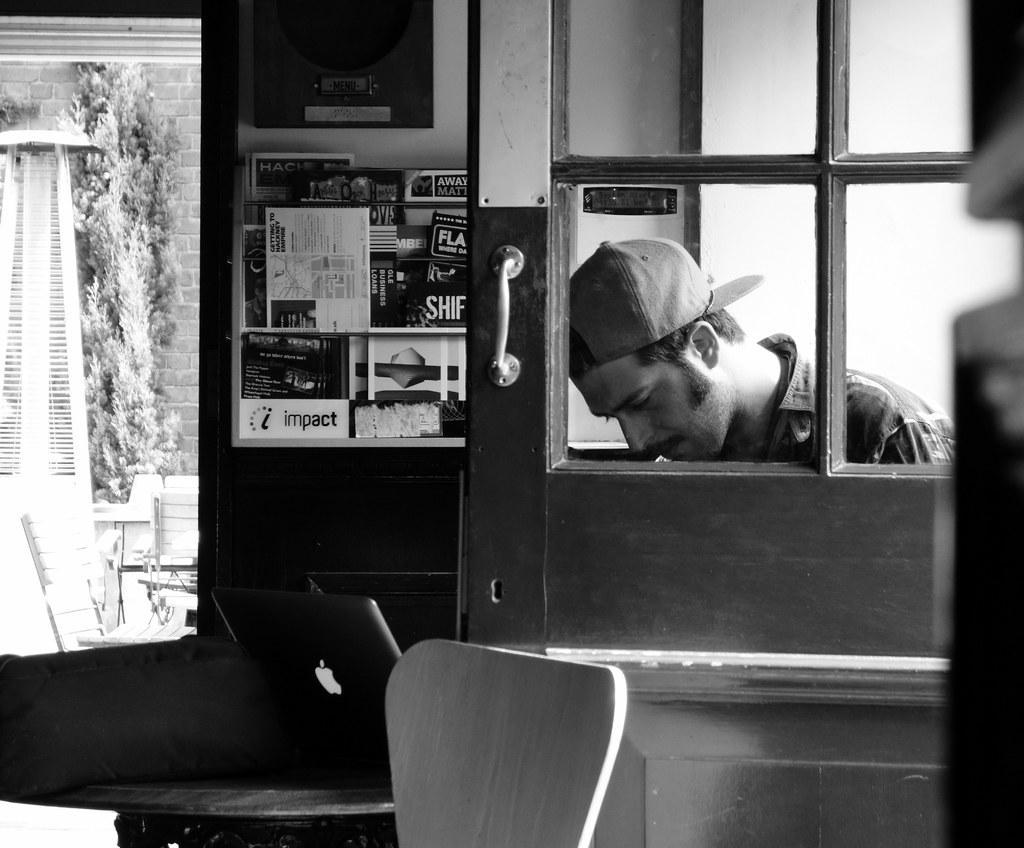Please provide a concise description of this image. In this image I can see the person with dress and cap. To the side of the person I can see the door. In the front I can see the laptop on the table. To the side I can see the chair. In the background I can see the window and there is a white color object, tree and the wall can be seen through the window. 